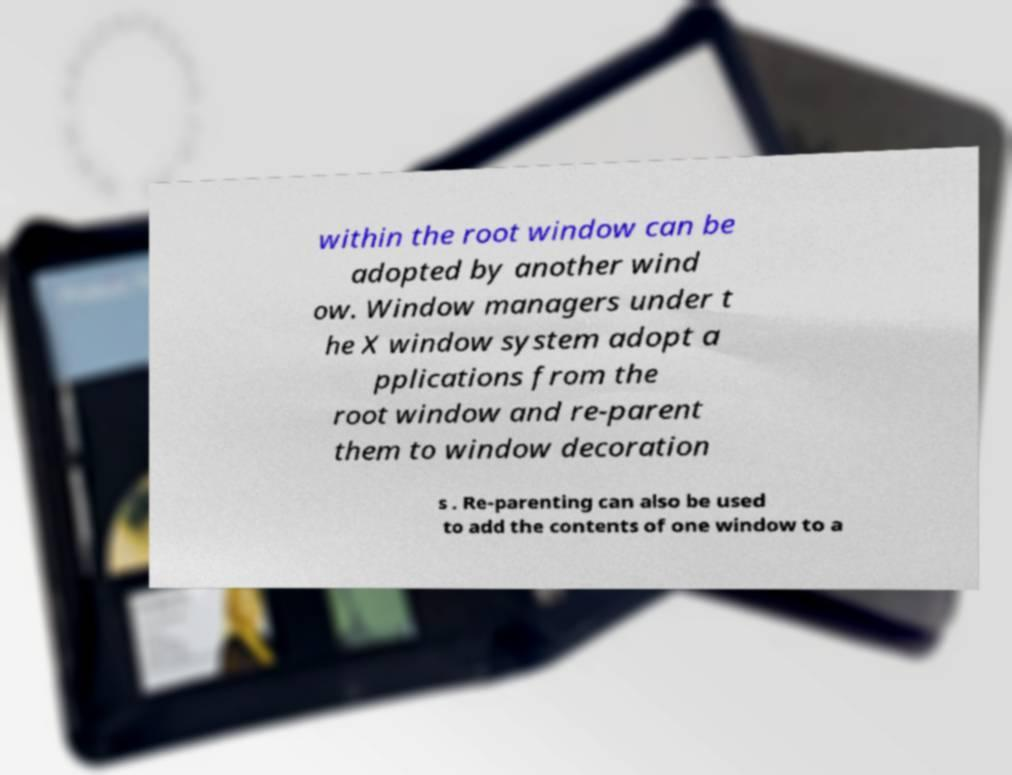I need the written content from this picture converted into text. Can you do that? within the root window can be adopted by another wind ow. Window managers under t he X window system adopt a pplications from the root window and re-parent them to window decoration s . Re-parenting can also be used to add the contents of one window to a 